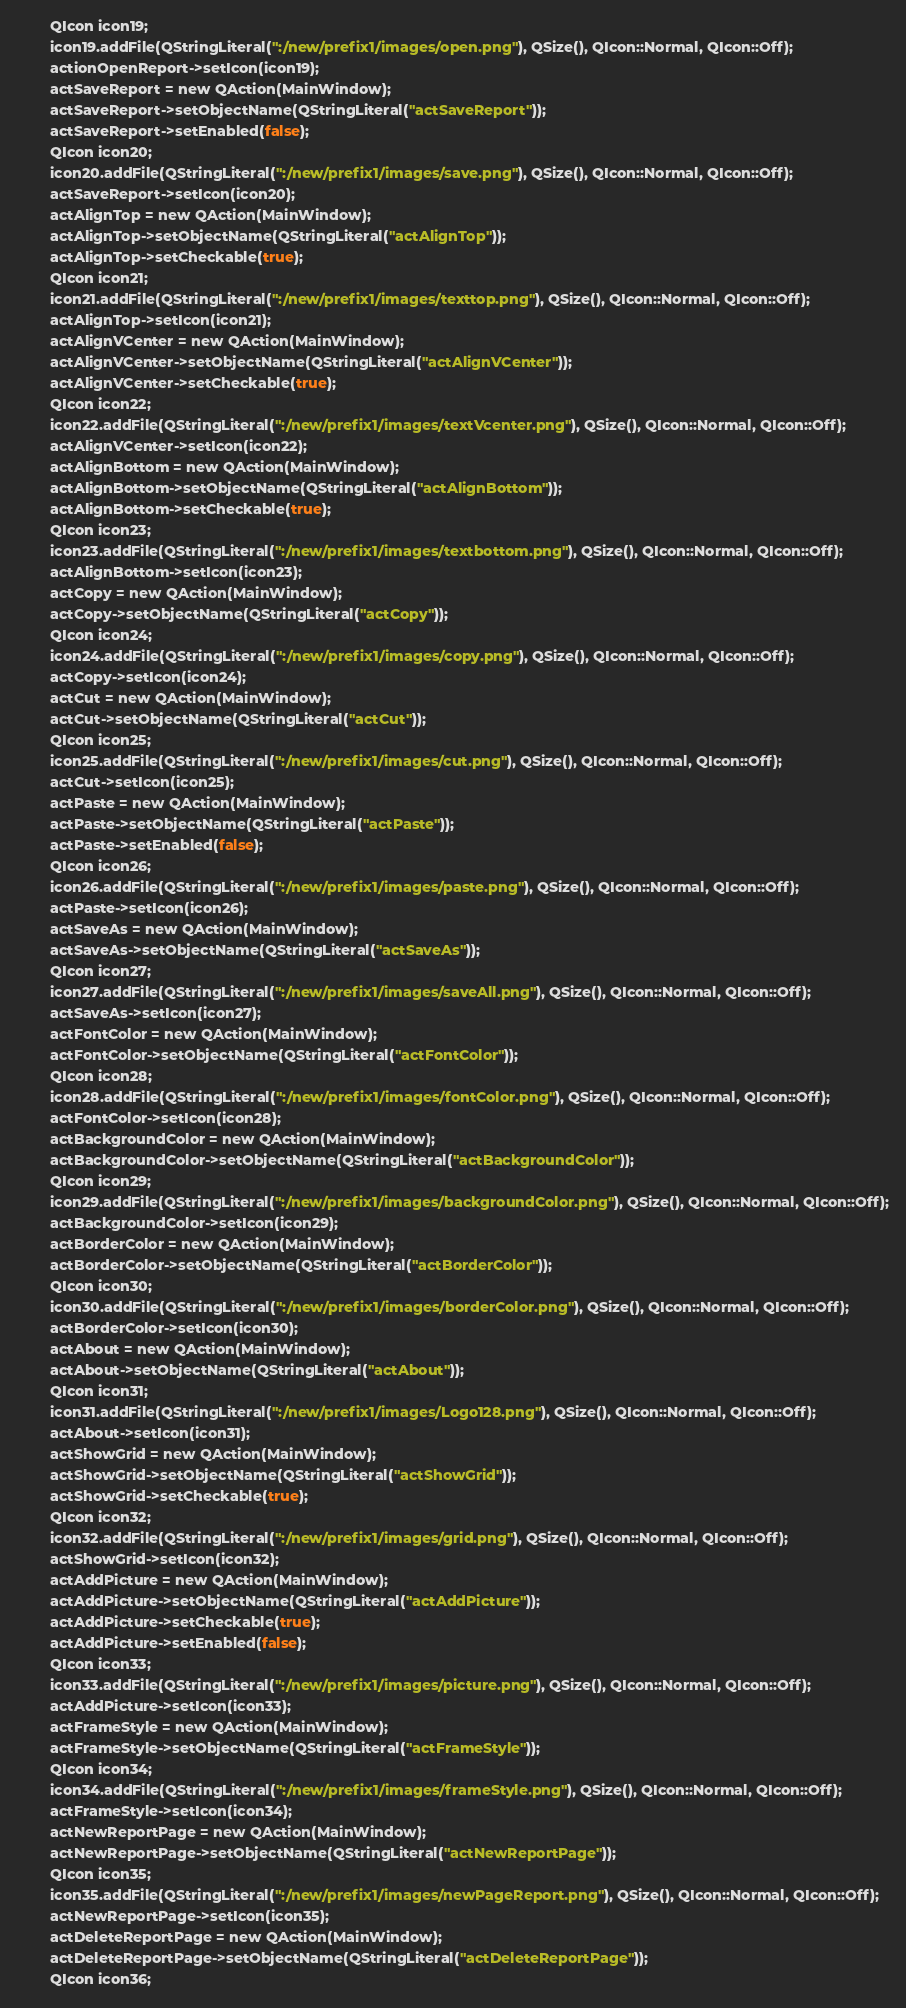Convert code to text. <code><loc_0><loc_0><loc_500><loc_500><_C_>        QIcon icon19;
        icon19.addFile(QStringLiteral(":/new/prefix1/images/open.png"), QSize(), QIcon::Normal, QIcon::Off);
        actionOpenReport->setIcon(icon19);
        actSaveReport = new QAction(MainWindow);
        actSaveReport->setObjectName(QStringLiteral("actSaveReport"));
        actSaveReport->setEnabled(false);
        QIcon icon20;
        icon20.addFile(QStringLiteral(":/new/prefix1/images/save.png"), QSize(), QIcon::Normal, QIcon::Off);
        actSaveReport->setIcon(icon20);
        actAlignTop = new QAction(MainWindow);
        actAlignTop->setObjectName(QStringLiteral("actAlignTop"));
        actAlignTop->setCheckable(true);
        QIcon icon21;
        icon21.addFile(QStringLiteral(":/new/prefix1/images/texttop.png"), QSize(), QIcon::Normal, QIcon::Off);
        actAlignTop->setIcon(icon21);
        actAlignVCenter = new QAction(MainWindow);
        actAlignVCenter->setObjectName(QStringLiteral("actAlignVCenter"));
        actAlignVCenter->setCheckable(true);
        QIcon icon22;
        icon22.addFile(QStringLiteral(":/new/prefix1/images/textVcenter.png"), QSize(), QIcon::Normal, QIcon::Off);
        actAlignVCenter->setIcon(icon22);
        actAlignBottom = new QAction(MainWindow);
        actAlignBottom->setObjectName(QStringLiteral("actAlignBottom"));
        actAlignBottom->setCheckable(true);
        QIcon icon23;
        icon23.addFile(QStringLiteral(":/new/prefix1/images/textbottom.png"), QSize(), QIcon::Normal, QIcon::Off);
        actAlignBottom->setIcon(icon23);
        actCopy = new QAction(MainWindow);
        actCopy->setObjectName(QStringLiteral("actCopy"));
        QIcon icon24;
        icon24.addFile(QStringLiteral(":/new/prefix1/images/copy.png"), QSize(), QIcon::Normal, QIcon::Off);
        actCopy->setIcon(icon24);
        actCut = new QAction(MainWindow);
        actCut->setObjectName(QStringLiteral("actCut"));
        QIcon icon25;
        icon25.addFile(QStringLiteral(":/new/prefix1/images/cut.png"), QSize(), QIcon::Normal, QIcon::Off);
        actCut->setIcon(icon25);
        actPaste = new QAction(MainWindow);
        actPaste->setObjectName(QStringLiteral("actPaste"));
        actPaste->setEnabled(false);
        QIcon icon26;
        icon26.addFile(QStringLiteral(":/new/prefix1/images/paste.png"), QSize(), QIcon::Normal, QIcon::Off);
        actPaste->setIcon(icon26);
        actSaveAs = new QAction(MainWindow);
        actSaveAs->setObjectName(QStringLiteral("actSaveAs"));
        QIcon icon27;
        icon27.addFile(QStringLiteral(":/new/prefix1/images/saveAll.png"), QSize(), QIcon::Normal, QIcon::Off);
        actSaveAs->setIcon(icon27);
        actFontColor = new QAction(MainWindow);
        actFontColor->setObjectName(QStringLiteral("actFontColor"));
        QIcon icon28;
        icon28.addFile(QStringLiteral(":/new/prefix1/images/fontColor.png"), QSize(), QIcon::Normal, QIcon::Off);
        actFontColor->setIcon(icon28);
        actBackgroundColor = new QAction(MainWindow);
        actBackgroundColor->setObjectName(QStringLiteral("actBackgroundColor"));
        QIcon icon29;
        icon29.addFile(QStringLiteral(":/new/prefix1/images/backgroundColor.png"), QSize(), QIcon::Normal, QIcon::Off);
        actBackgroundColor->setIcon(icon29);
        actBorderColor = new QAction(MainWindow);
        actBorderColor->setObjectName(QStringLiteral("actBorderColor"));
        QIcon icon30;
        icon30.addFile(QStringLiteral(":/new/prefix1/images/borderColor.png"), QSize(), QIcon::Normal, QIcon::Off);
        actBorderColor->setIcon(icon30);
        actAbout = new QAction(MainWindow);
        actAbout->setObjectName(QStringLiteral("actAbout"));
        QIcon icon31;
        icon31.addFile(QStringLiteral(":/new/prefix1/images/Logo128.png"), QSize(), QIcon::Normal, QIcon::Off);
        actAbout->setIcon(icon31);
        actShowGrid = new QAction(MainWindow);
        actShowGrid->setObjectName(QStringLiteral("actShowGrid"));
        actShowGrid->setCheckable(true);
        QIcon icon32;
        icon32.addFile(QStringLiteral(":/new/prefix1/images/grid.png"), QSize(), QIcon::Normal, QIcon::Off);
        actShowGrid->setIcon(icon32);
        actAddPicture = new QAction(MainWindow);
        actAddPicture->setObjectName(QStringLiteral("actAddPicture"));
        actAddPicture->setCheckable(true);
        actAddPicture->setEnabled(false);
        QIcon icon33;
        icon33.addFile(QStringLiteral(":/new/prefix1/images/picture.png"), QSize(), QIcon::Normal, QIcon::Off);
        actAddPicture->setIcon(icon33);
        actFrameStyle = new QAction(MainWindow);
        actFrameStyle->setObjectName(QStringLiteral("actFrameStyle"));
        QIcon icon34;
        icon34.addFile(QStringLiteral(":/new/prefix1/images/frameStyle.png"), QSize(), QIcon::Normal, QIcon::Off);
        actFrameStyle->setIcon(icon34);
        actNewReportPage = new QAction(MainWindow);
        actNewReportPage->setObjectName(QStringLiteral("actNewReportPage"));
        QIcon icon35;
        icon35.addFile(QStringLiteral(":/new/prefix1/images/newPageReport.png"), QSize(), QIcon::Normal, QIcon::Off);
        actNewReportPage->setIcon(icon35);
        actDeleteReportPage = new QAction(MainWindow);
        actDeleteReportPage->setObjectName(QStringLiteral("actDeleteReportPage"));
        QIcon icon36;</code> 